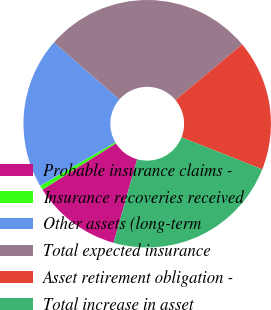Convert chart to OTSL. <chart><loc_0><loc_0><loc_500><loc_500><pie_chart><fcel>Probable insurance claims -<fcel>Insurance recoveries received<fcel>Other assets (long-term<fcel>Total expected insurance<fcel>Asset retirement obligation -<fcel>Total increase in asset<nl><fcel>11.69%<fcel>0.57%<fcel>19.77%<fcel>27.51%<fcel>17.08%<fcel>23.38%<nl></chart> 